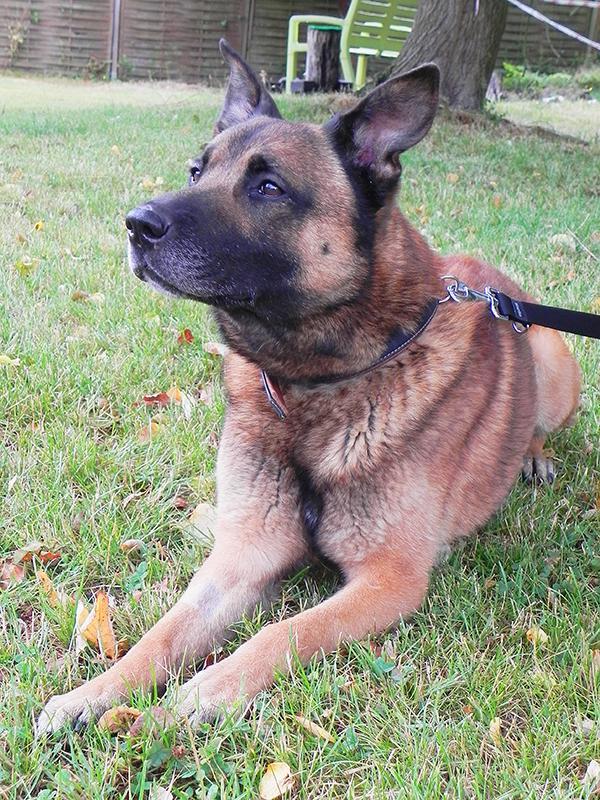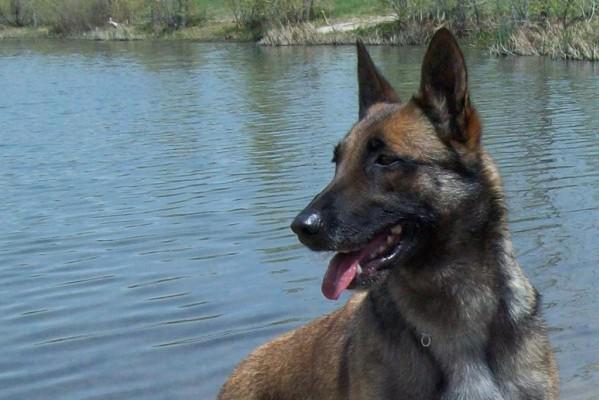The first image is the image on the left, the second image is the image on the right. Considering the images on both sides, is "There are two dogs standing in the grass." valid? Answer yes or no. No. The first image is the image on the left, the second image is the image on the right. Evaluate the accuracy of this statement regarding the images: "There are 2 dogs standing.". Is it true? Answer yes or no. No. 